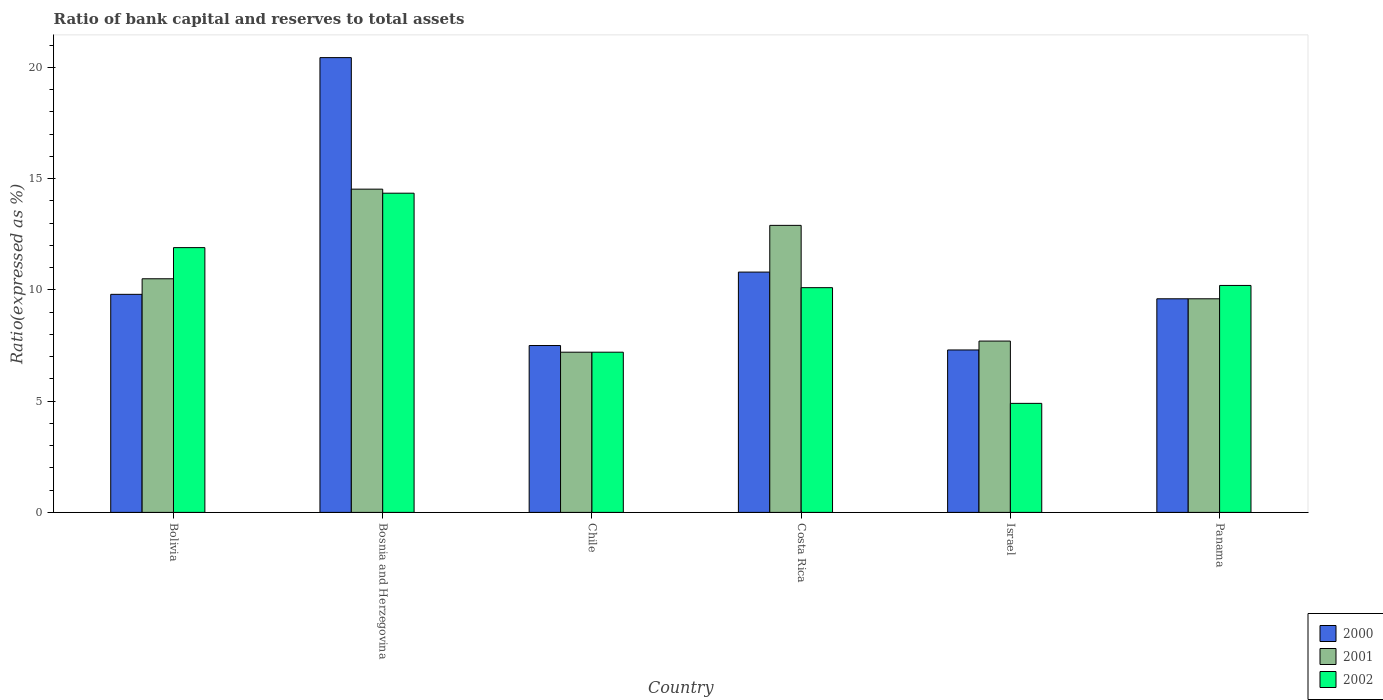How many groups of bars are there?
Ensure brevity in your answer.  6. Are the number of bars per tick equal to the number of legend labels?
Offer a terse response. Yes. How many bars are there on the 5th tick from the left?
Your response must be concise. 3. How many bars are there on the 4th tick from the right?
Your answer should be very brief. 3. What is the label of the 4th group of bars from the left?
Ensure brevity in your answer.  Costa Rica. In how many cases, is the number of bars for a given country not equal to the number of legend labels?
Make the answer very short. 0. What is the ratio of bank capital and reserves to total assets in 2000 in Bolivia?
Keep it short and to the point. 9.8. Across all countries, what is the maximum ratio of bank capital and reserves to total assets in 2002?
Offer a very short reply. 14.35. Across all countries, what is the minimum ratio of bank capital and reserves to total assets in 2002?
Ensure brevity in your answer.  4.9. In which country was the ratio of bank capital and reserves to total assets in 2000 maximum?
Keep it short and to the point. Bosnia and Herzegovina. What is the total ratio of bank capital and reserves to total assets in 2002 in the graph?
Offer a very short reply. 58.65. What is the difference between the ratio of bank capital and reserves to total assets in 2001 in Chile and that in Panama?
Your answer should be compact. -2.4. What is the difference between the ratio of bank capital and reserves to total assets in 2002 in Costa Rica and the ratio of bank capital and reserves to total assets in 2001 in Bolivia?
Keep it short and to the point. -0.4. What is the average ratio of bank capital and reserves to total assets in 2001 per country?
Provide a short and direct response. 10.4. In how many countries, is the ratio of bank capital and reserves to total assets in 2001 greater than 4 %?
Your answer should be very brief. 6. What is the ratio of the ratio of bank capital and reserves to total assets in 2000 in Bosnia and Herzegovina to that in Panama?
Provide a succinct answer. 2.13. What is the difference between the highest and the lowest ratio of bank capital and reserves to total assets in 2001?
Keep it short and to the point. 7.33. In how many countries, is the ratio of bank capital and reserves to total assets in 2002 greater than the average ratio of bank capital and reserves to total assets in 2002 taken over all countries?
Your answer should be very brief. 4. What does the 2nd bar from the left in Panama represents?
Keep it short and to the point. 2001. How many bars are there?
Ensure brevity in your answer.  18. How many countries are there in the graph?
Provide a succinct answer. 6. Does the graph contain grids?
Provide a succinct answer. No. How are the legend labels stacked?
Your answer should be very brief. Vertical. What is the title of the graph?
Your response must be concise. Ratio of bank capital and reserves to total assets. What is the label or title of the Y-axis?
Your response must be concise. Ratio(expressed as %). What is the Ratio(expressed as %) in 2000 in Bosnia and Herzegovina?
Give a very brief answer. 20.44. What is the Ratio(expressed as %) of 2001 in Bosnia and Herzegovina?
Ensure brevity in your answer.  14.53. What is the Ratio(expressed as %) of 2002 in Bosnia and Herzegovina?
Your answer should be compact. 14.35. What is the Ratio(expressed as %) of 2001 in Costa Rica?
Make the answer very short. 12.9. What is the Ratio(expressed as %) in 2002 in Costa Rica?
Your response must be concise. 10.1. What is the Ratio(expressed as %) of 2001 in Israel?
Give a very brief answer. 7.7. What is the Ratio(expressed as %) in 2002 in Israel?
Offer a very short reply. 4.9. What is the Ratio(expressed as %) of 2000 in Panama?
Give a very brief answer. 9.6. What is the Ratio(expressed as %) in 2001 in Panama?
Offer a terse response. 9.6. What is the Ratio(expressed as %) in 2002 in Panama?
Provide a short and direct response. 10.2. Across all countries, what is the maximum Ratio(expressed as %) of 2000?
Your answer should be very brief. 20.44. Across all countries, what is the maximum Ratio(expressed as %) of 2001?
Offer a very short reply. 14.53. Across all countries, what is the maximum Ratio(expressed as %) in 2002?
Your answer should be very brief. 14.35. Across all countries, what is the minimum Ratio(expressed as %) in 2002?
Keep it short and to the point. 4.9. What is the total Ratio(expressed as %) in 2000 in the graph?
Make the answer very short. 65.44. What is the total Ratio(expressed as %) of 2001 in the graph?
Give a very brief answer. 62.43. What is the total Ratio(expressed as %) of 2002 in the graph?
Offer a terse response. 58.65. What is the difference between the Ratio(expressed as %) of 2000 in Bolivia and that in Bosnia and Herzegovina?
Give a very brief answer. -10.64. What is the difference between the Ratio(expressed as %) of 2001 in Bolivia and that in Bosnia and Herzegovina?
Keep it short and to the point. -4.03. What is the difference between the Ratio(expressed as %) in 2002 in Bolivia and that in Bosnia and Herzegovina?
Provide a short and direct response. -2.45. What is the difference between the Ratio(expressed as %) in 2000 in Bolivia and that in Costa Rica?
Provide a short and direct response. -1. What is the difference between the Ratio(expressed as %) of 2001 in Bolivia and that in Costa Rica?
Your answer should be very brief. -2.4. What is the difference between the Ratio(expressed as %) of 2002 in Bolivia and that in Costa Rica?
Offer a terse response. 1.8. What is the difference between the Ratio(expressed as %) of 2000 in Bolivia and that in Israel?
Your answer should be very brief. 2.5. What is the difference between the Ratio(expressed as %) in 2001 in Bolivia and that in Israel?
Your response must be concise. 2.8. What is the difference between the Ratio(expressed as %) in 2002 in Bolivia and that in Israel?
Ensure brevity in your answer.  7. What is the difference between the Ratio(expressed as %) of 2001 in Bolivia and that in Panama?
Keep it short and to the point. 0.9. What is the difference between the Ratio(expressed as %) in 2002 in Bolivia and that in Panama?
Make the answer very short. 1.7. What is the difference between the Ratio(expressed as %) in 2000 in Bosnia and Herzegovina and that in Chile?
Provide a succinct answer. 12.94. What is the difference between the Ratio(expressed as %) of 2001 in Bosnia and Herzegovina and that in Chile?
Offer a very short reply. 7.33. What is the difference between the Ratio(expressed as %) in 2002 in Bosnia and Herzegovina and that in Chile?
Your answer should be compact. 7.15. What is the difference between the Ratio(expressed as %) in 2000 in Bosnia and Herzegovina and that in Costa Rica?
Offer a terse response. 9.64. What is the difference between the Ratio(expressed as %) of 2001 in Bosnia and Herzegovina and that in Costa Rica?
Offer a terse response. 1.63. What is the difference between the Ratio(expressed as %) in 2002 in Bosnia and Herzegovina and that in Costa Rica?
Provide a succinct answer. 4.25. What is the difference between the Ratio(expressed as %) in 2000 in Bosnia and Herzegovina and that in Israel?
Keep it short and to the point. 13.14. What is the difference between the Ratio(expressed as %) in 2001 in Bosnia and Herzegovina and that in Israel?
Provide a short and direct response. 6.83. What is the difference between the Ratio(expressed as %) in 2002 in Bosnia and Herzegovina and that in Israel?
Your answer should be compact. 9.45. What is the difference between the Ratio(expressed as %) of 2000 in Bosnia and Herzegovina and that in Panama?
Provide a succinct answer. 10.84. What is the difference between the Ratio(expressed as %) in 2001 in Bosnia and Herzegovina and that in Panama?
Your answer should be compact. 4.93. What is the difference between the Ratio(expressed as %) of 2002 in Bosnia and Herzegovina and that in Panama?
Keep it short and to the point. 4.15. What is the difference between the Ratio(expressed as %) of 2001 in Chile and that in Costa Rica?
Your answer should be very brief. -5.7. What is the difference between the Ratio(expressed as %) of 2000 in Chile and that in Panama?
Your answer should be very brief. -2.1. What is the difference between the Ratio(expressed as %) of 2001 in Chile and that in Panama?
Your answer should be very brief. -2.4. What is the difference between the Ratio(expressed as %) in 2000 in Costa Rica and that in Israel?
Provide a short and direct response. 3.5. What is the difference between the Ratio(expressed as %) in 2001 in Costa Rica and that in Israel?
Provide a short and direct response. 5.2. What is the difference between the Ratio(expressed as %) of 2002 in Costa Rica and that in Panama?
Give a very brief answer. -0.1. What is the difference between the Ratio(expressed as %) in 2000 in Bolivia and the Ratio(expressed as %) in 2001 in Bosnia and Herzegovina?
Offer a very short reply. -4.73. What is the difference between the Ratio(expressed as %) in 2000 in Bolivia and the Ratio(expressed as %) in 2002 in Bosnia and Herzegovina?
Keep it short and to the point. -4.55. What is the difference between the Ratio(expressed as %) of 2001 in Bolivia and the Ratio(expressed as %) of 2002 in Bosnia and Herzegovina?
Your answer should be very brief. -3.85. What is the difference between the Ratio(expressed as %) in 2000 in Bolivia and the Ratio(expressed as %) in 2002 in Chile?
Your answer should be very brief. 2.6. What is the difference between the Ratio(expressed as %) of 2000 in Bolivia and the Ratio(expressed as %) of 2002 in Costa Rica?
Make the answer very short. -0.3. What is the difference between the Ratio(expressed as %) in 2000 in Bolivia and the Ratio(expressed as %) in 2002 in Israel?
Offer a terse response. 4.9. What is the difference between the Ratio(expressed as %) in 2001 in Bolivia and the Ratio(expressed as %) in 2002 in Israel?
Provide a short and direct response. 5.6. What is the difference between the Ratio(expressed as %) in 2000 in Bolivia and the Ratio(expressed as %) in 2001 in Panama?
Provide a short and direct response. 0.2. What is the difference between the Ratio(expressed as %) of 2001 in Bolivia and the Ratio(expressed as %) of 2002 in Panama?
Your answer should be very brief. 0.3. What is the difference between the Ratio(expressed as %) in 2000 in Bosnia and Herzegovina and the Ratio(expressed as %) in 2001 in Chile?
Provide a short and direct response. 13.24. What is the difference between the Ratio(expressed as %) in 2000 in Bosnia and Herzegovina and the Ratio(expressed as %) in 2002 in Chile?
Your answer should be compact. 13.24. What is the difference between the Ratio(expressed as %) of 2001 in Bosnia and Herzegovina and the Ratio(expressed as %) of 2002 in Chile?
Offer a very short reply. 7.33. What is the difference between the Ratio(expressed as %) in 2000 in Bosnia and Herzegovina and the Ratio(expressed as %) in 2001 in Costa Rica?
Provide a short and direct response. 7.54. What is the difference between the Ratio(expressed as %) of 2000 in Bosnia and Herzegovina and the Ratio(expressed as %) of 2002 in Costa Rica?
Give a very brief answer. 10.34. What is the difference between the Ratio(expressed as %) of 2001 in Bosnia and Herzegovina and the Ratio(expressed as %) of 2002 in Costa Rica?
Give a very brief answer. 4.43. What is the difference between the Ratio(expressed as %) of 2000 in Bosnia and Herzegovina and the Ratio(expressed as %) of 2001 in Israel?
Keep it short and to the point. 12.74. What is the difference between the Ratio(expressed as %) in 2000 in Bosnia and Herzegovina and the Ratio(expressed as %) in 2002 in Israel?
Keep it short and to the point. 15.54. What is the difference between the Ratio(expressed as %) of 2001 in Bosnia and Herzegovina and the Ratio(expressed as %) of 2002 in Israel?
Offer a terse response. 9.63. What is the difference between the Ratio(expressed as %) in 2000 in Bosnia and Herzegovina and the Ratio(expressed as %) in 2001 in Panama?
Provide a short and direct response. 10.84. What is the difference between the Ratio(expressed as %) in 2000 in Bosnia and Herzegovina and the Ratio(expressed as %) in 2002 in Panama?
Your answer should be very brief. 10.24. What is the difference between the Ratio(expressed as %) in 2001 in Bosnia and Herzegovina and the Ratio(expressed as %) in 2002 in Panama?
Your answer should be very brief. 4.33. What is the difference between the Ratio(expressed as %) of 2000 in Chile and the Ratio(expressed as %) of 2001 in Costa Rica?
Make the answer very short. -5.4. What is the difference between the Ratio(expressed as %) of 2001 in Chile and the Ratio(expressed as %) of 2002 in Costa Rica?
Offer a very short reply. -2.9. What is the difference between the Ratio(expressed as %) in 2000 in Chile and the Ratio(expressed as %) in 2001 in Israel?
Ensure brevity in your answer.  -0.2. What is the difference between the Ratio(expressed as %) of 2000 in Chile and the Ratio(expressed as %) of 2001 in Panama?
Offer a terse response. -2.1. What is the difference between the Ratio(expressed as %) of 2000 in Costa Rica and the Ratio(expressed as %) of 2002 in Israel?
Your answer should be very brief. 5.9. What is the difference between the Ratio(expressed as %) of 2001 in Costa Rica and the Ratio(expressed as %) of 2002 in Israel?
Offer a very short reply. 8. What is the difference between the Ratio(expressed as %) of 2001 in Costa Rica and the Ratio(expressed as %) of 2002 in Panama?
Offer a very short reply. 2.7. What is the difference between the Ratio(expressed as %) of 2000 in Israel and the Ratio(expressed as %) of 2002 in Panama?
Provide a short and direct response. -2.9. What is the difference between the Ratio(expressed as %) of 2001 in Israel and the Ratio(expressed as %) of 2002 in Panama?
Your answer should be very brief. -2.5. What is the average Ratio(expressed as %) of 2000 per country?
Your answer should be very brief. 10.91. What is the average Ratio(expressed as %) in 2001 per country?
Ensure brevity in your answer.  10.4. What is the average Ratio(expressed as %) in 2002 per country?
Provide a short and direct response. 9.77. What is the difference between the Ratio(expressed as %) of 2000 and Ratio(expressed as %) of 2001 in Bolivia?
Your response must be concise. -0.7. What is the difference between the Ratio(expressed as %) of 2000 and Ratio(expressed as %) of 2002 in Bolivia?
Make the answer very short. -2.1. What is the difference between the Ratio(expressed as %) in 2000 and Ratio(expressed as %) in 2001 in Bosnia and Herzegovina?
Keep it short and to the point. 5.91. What is the difference between the Ratio(expressed as %) in 2000 and Ratio(expressed as %) in 2002 in Bosnia and Herzegovina?
Your answer should be compact. 6.09. What is the difference between the Ratio(expressed as %) of 2001 and Ratio(expressed as %) of 2002 in Bosnia and Herzegovina?
Provide a succinct answer. 0.18. What is the difference between the Ratio(expressed as %) of 2000 and Ratio(expressed as %) of 2001 in Chile?
Your answer should be compact. 0.3. What is the difference between the Ratio(expressed as %) in 2000 and Ratio(expressed as %) in 2002 in Chile?
Offer a terse response. 0.3. What is the difference between the Ratio(expressed as %) in 2001 and Ratio(expressed as %) in 2002 in Costa Rica?
Offer a terse response. 2.8. What is the difference between the Ratio(expressed as %) in 2000 and Ratio(expressed as %) in 2001 in Israel?
Ensure brevity in your answer.  -0.4. What is the difference between the Ratio(expressed as %) in 2000 and Ratio(expressed as %) in 2002 in Panama?
Keep it short and to the point. -0.6. What is the ratio of the Ratio(expressed as %) in 2000 in Bolivia to that in Bosnia and Herzegovina?
Your answer should be compact. 0.48. What is the ratio of the Ratio(expressed as %) of 2001 in Bolivia to that in Bosnia and Herzegovina?
Give a very brief answer. 0.72. What is the ratio of the Ratio(expressed as %) in 2002 in Bolivia to that in Bosnia and Herzegovina?
Your answer should be very brief. 0.83. What is the ratio of the Ratio(expressed as %) of 2000 in Bolivia to that in Chile?
Your response must be concise. 1.31. What is the ratio of the Ratio(expressed as %) of 2001 in Bolivia to that in Chile?
Provide a short and direct response. 1.46. What is the ratio of the Ratio(expressed as %) of 2002 in Bolivia to that in Chile?
Make the answer very short. 1.65. What is the ratio of the Ratio(expressed as %) in 2000 in Bolivia to that in Costa Rica?
Your answer should be very brief. 0.91. What is the ratio of the Ratio(expressed as %) of 2001 in Bolivia to that in Costa Rica?
Make the answer very short. 0.81. What is the ratio of the Ratio(expressed as %) in 2002 in Bolivia to that in Costa Rica?
Your answer should be compact. 1.18. What is the ratio of the Ratio(expressed as %) of 2000 in Bolivia to that in Israel?
Provide a succinct answer. 1.34. What is the ratio of the Ratio(expressed as %) of 2001 in Bolivia to that in Israel?
Provide a succinct answer. 1.36. What is the ratio of the Ratio(expressed as %) of 2002 in Bolivia to that in Israel?
Give a very brief answer. 2.43. What is the ratio of the Ratio(expressed as %) of 2000 in Bolivia to that in Panama?
Ensure brevity in your answer.  1.02. What is the ratio of the Ratio(expressed as %) of 2001 in Bolivia to that in Panama?
Your answer should be very brief. 1.09. What is the ratio of the Ratio(expressed as %) of 2002 in Bolivia to that in Panama?
Offer a terse response. 1.17. What is the ratio of the Ratio(expressed as %) of 2000 in Bosnia and Herzegovina to that in Chile?
Offer a terse response. 2.73. What is the ratio of the Ratio(expressed as %) in 2001 in Bosnia and Herzegovina to that in Chile?
Provide a succinct answer. 2.02. What is the ratio of the Ratio(expressed as %) in 2002 in Bosnia and Herzegovina to that in Chile?
Provide a succinct answer. 1.99. What is the ratio of the Ratio(expressed as %) of 2000 in Bosnia and Herzegovina to that in Costa Rica?
Offer a very short reply. 1.89. What is the ratio of the Ratio(expressed as %) of 2001 in Bosnia and Herzegovina to that in Costa Rica?
Your answer should be very brief. 1.13. What is the ratio of the Ratio(expressed as %) in 2002 in Bosnia and Herzegovina to that in Costa Rica?
Your answer should be very brief. 1.42. What is the ratio of the Ratio(expressed as %) of 2000 in Bosnia and Herzegovina to that in Israel?
Make the answer very short. 2.8. What is the ratio of the Ratio(expressed as %) in 2001 in Bosnia and Herzegovina to that in Israel?
Offer a very short reply. 1.89. What is the ratio of the Ratio(expressed as %) in 2002 in Bosnia and Herzegovina to that in Israel?
Your answer should be compact. 2.93. What is the ratio of the Ratio(expressed as %) of 2000 in Bosnia and Herzegovina to that in Panama?
Provide a succinct answer. 2.13. What is the ratio of the Ratio(expressed as %) of 2001 in Bosnia and Herzegovina to that in Panama?
Keep it short and to the point. 1.51. What is the ratio of the Ratio(expressed as %) in 2002 in Bosnia and Herzegovina to that in Panama?
Make the answer very short. 1.41. What is the ratio of the Ratio(expressed as %) of 2000 in Chile to that in Costa Rica?
Ensure brevity in your answer.  0.69. What is the ratio of the Ratio(expressed as %) of 2001 in Chile to that in Costa Rica?
Make the answer very short. 0.56. What is the ratio of the Ratio(expressed as %) of 2002 in Chile to that in Costa Rica?
Keep it short and to the point. 0.71. What is the ratio of the Ratio(expressed as %) in 2000 in Chile to that in Israel?
Make the answer very short. 1.03. What is the ratio of the Ratio(expressed as %) of 2001 in Chile to that in Israel?
Ensure brevity in your answer.  0.94. What is the ratio of the Ratio(expressed as %) in 2002 in Chile to that in Israel?
Provide a succinct answer. 1.47. What is the ratio of the Ratio(expressed as %) in 2000 in Chile to that in Panama?
Make the answer very short. 0.78. What is the ratio of the Ratio(expressed as %) in 2001 in Chile to that in Panama?
Offer a very short reply. 0.75. What is the ratio of the Ratio(expressed as %) of 2002 in Chile to that in Panama?
Offer a terse response. 0.71. What is the ratio of the Ratio(expressed as %) of 2000 in Costa Rica to that in Israel?
Keep it short and to the point. 1.48. What is the ratio of the Ratio(expressed as %) of 2001 in Costa Rica to that in Israel?
Your answer should be compact. 1.68. What is the ratio of the Ratio(expressed as %) in 2002 in Costa Rica to that in Israel?
Give a very brief answer. 2.06. What is the ratio of the Ratio(expressed as %) in 2000 in Costa Rica to that in Panama?
Give a very brief answer. 1.12. What is the ratio of the Ratio(expressed as %) of 2001 in Costa Rica to that in Panama?
Ensure brevity in your answer.  1.34. What is the ratio of the Ratio(expressed as %) of 2002 in Costa Rica to that in Panama?
Your answer should be very brief. 0.99. What is the ratio of the Ratio(expressed as %) of 2000 in Israel to that in Panama?
Make the answer very short. 0.76. What is the ratio of the Ratio(expressed as %) in 2001 in Israel to that in Panama?
Your response must be concise. 0.8. What is the ratio of the Ratio(expressed as %) of 2002 in Israel to that in Panama?
Provide a short and direct response. 0.48. What is the difference between the highest and the second highest Ratio(expressed as %) in 2000?
Provide a short and direct response. 9.64. What is the difference between the highest and the second highest Ratio(expressed as %) in 2001?
Offer a terse response. 1.63. What is the difference between the highest and the second highest Ratio(expressed as %) of 2002?
Ensure brevity in your answer.  2.45. What is the difference between the highest and the lowest Ratio(expressed as %) in 2000?
Your answer should be very brief. 13.14. What is the difference between the highest and the lowest Ratio(expressed as %) of 2001?
Your response must be concise. 7.33. What is the difference between the highest and the lowest Ratio(expressed as %) in 2002?
Your answer should be compact. 9.45. 